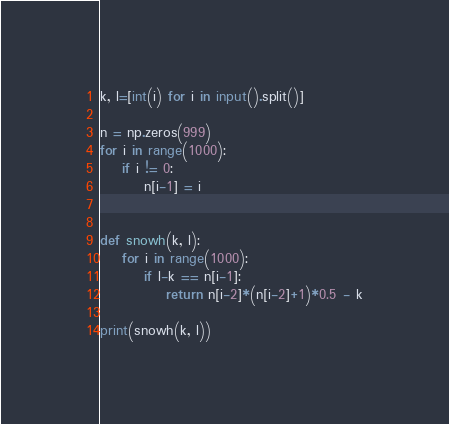<code> <loc_0><loc_0><loc_500><loc_500><_Python_>k, l=[int(i) for i in input().split()]

n = np.zeros(999)
for i in range(1000):
    if i != 0:
        n[i-1] = i


def snowh(k, l):
    for i in range(1000):
        if l-k == n[i-1]:
            return n[i-2]*(n[i-2]+1)*0.5 - k
        
print(snowh(k, l))</code> 